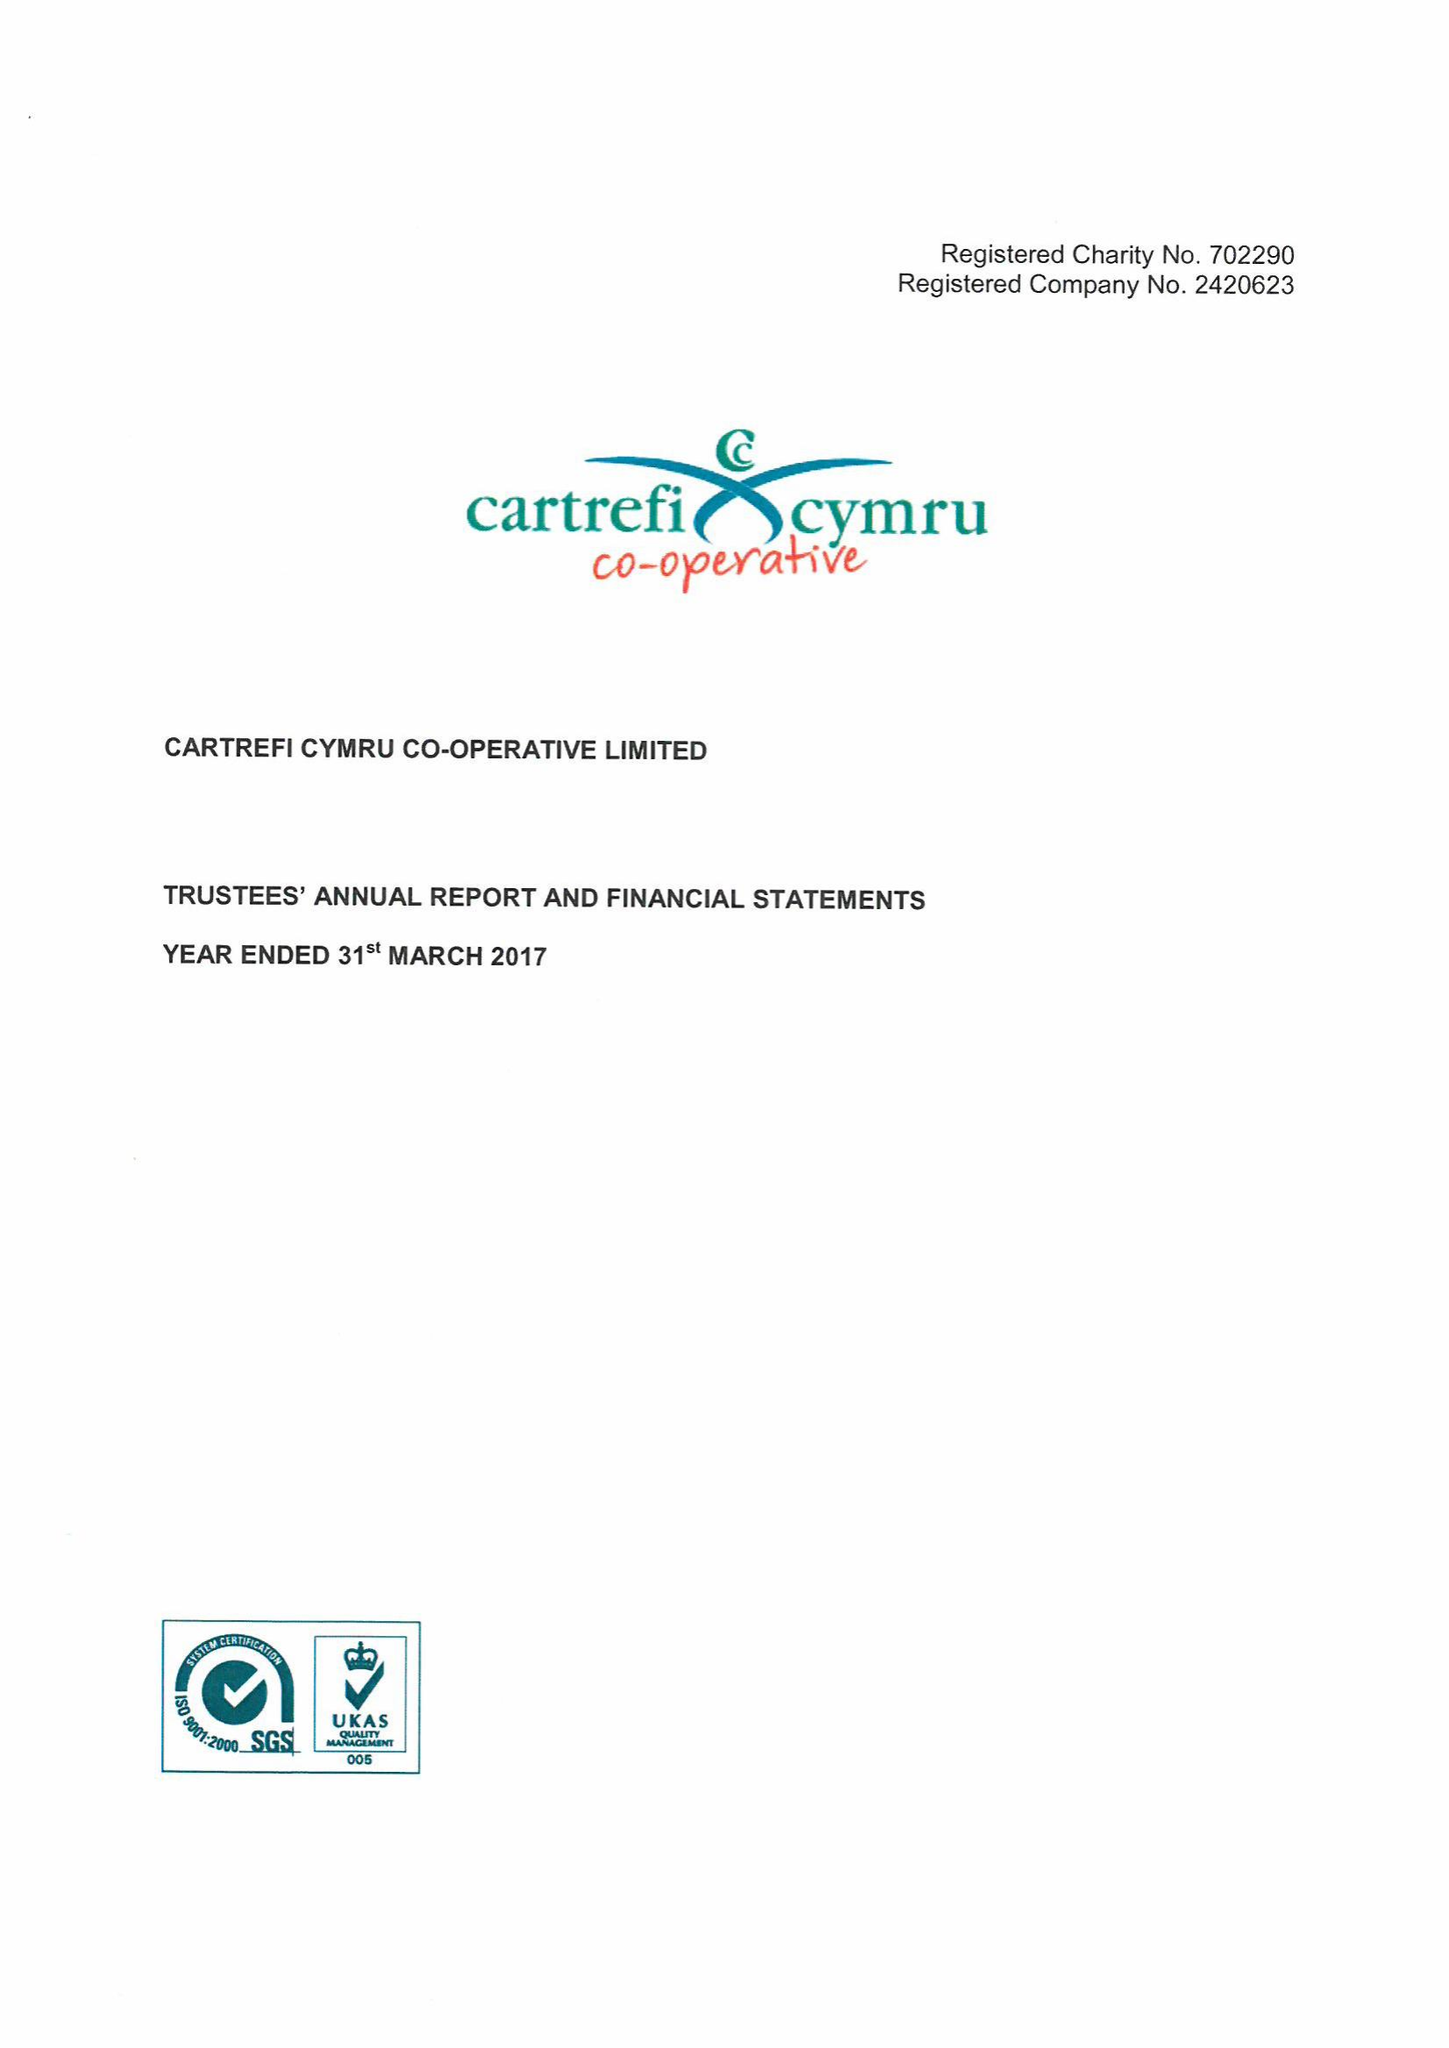What is the value for the spending_annually_in_british_pounds?
Answer the question using a single word or phrase. 21802000.00 